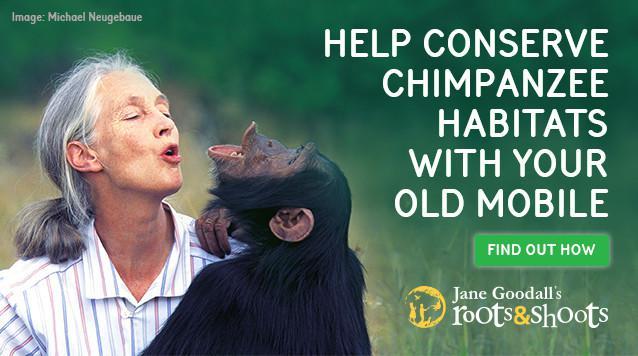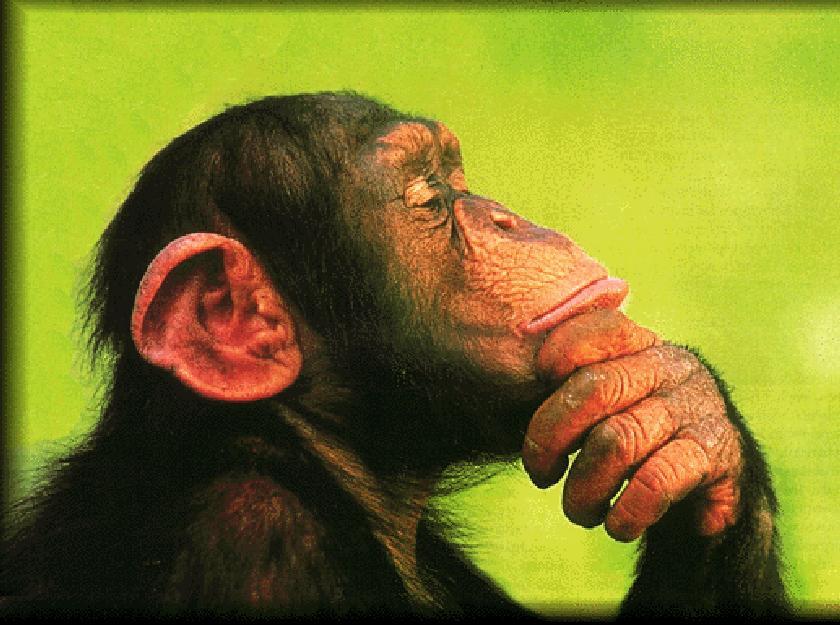The first image is the image on the left, the second image is the image on the right. For the images displayed, is the sentence "The right image contains exactly one chimpanzee." factually correct? Answer yes or no. Yes. The first image is the image on the left, the second image is the image on the right. Evaluate the accuracy of this statement regarding the images: "There is a single chimp outdoors in each of the images.". Is it true? Answer yes or no. Yes. 